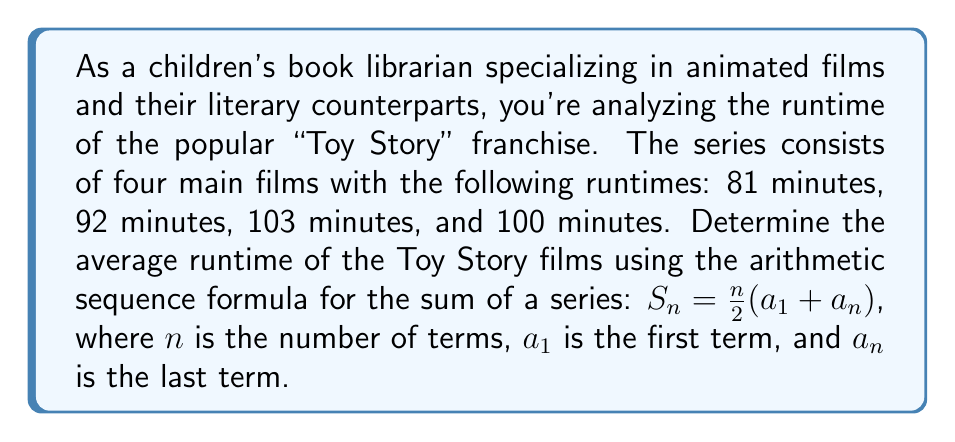Give your solution to this math problem. To solve this problem, we'll follow these steps:

1. Identify the given information:
   $n = 4$ (number of films)
   $a_1 = 81$ (runtime of the first film)
   $a_n = a_4 = 100$ (runtime of the last film)

2. Use the arithmetic sequence formula to find the sum of the runtimes:
   $$S_n = \frac{n}{2}(a_1 + a_n)$$
   $$S_4 = \frac{4}{2}(81 + 100)$$
   $$S_4 = 2(181)$$
   $$S_4 = 362$$

3. Calculate the average runtime by dividing the sum by the number of films:
   $$\text{Average} = \frac{S_4}{n} = \frac{362}{4} = 90.5$$

Therefore, the average runtime of the Toy Story films is 90.5 minutes.
Answer: The average runtime of the Toy Story franchise films is 90.5 minutes. 